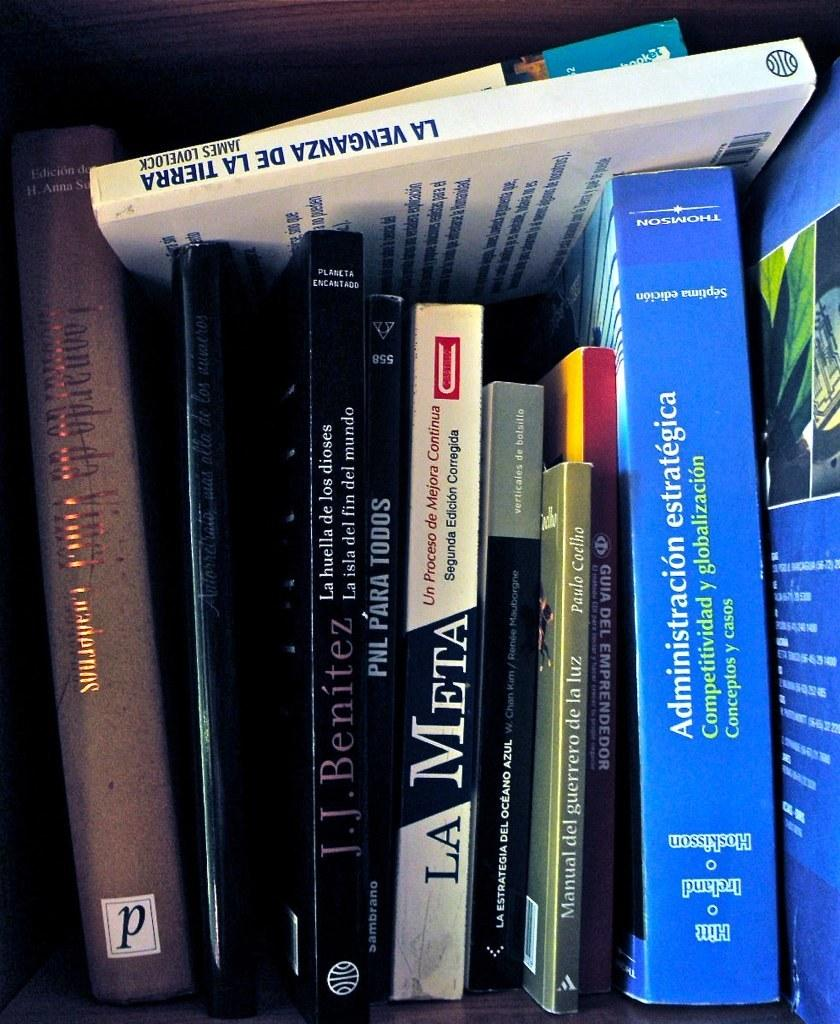Provide a one-sentence caption for the provided image. A stack of books in different languages, one being La Meta. 